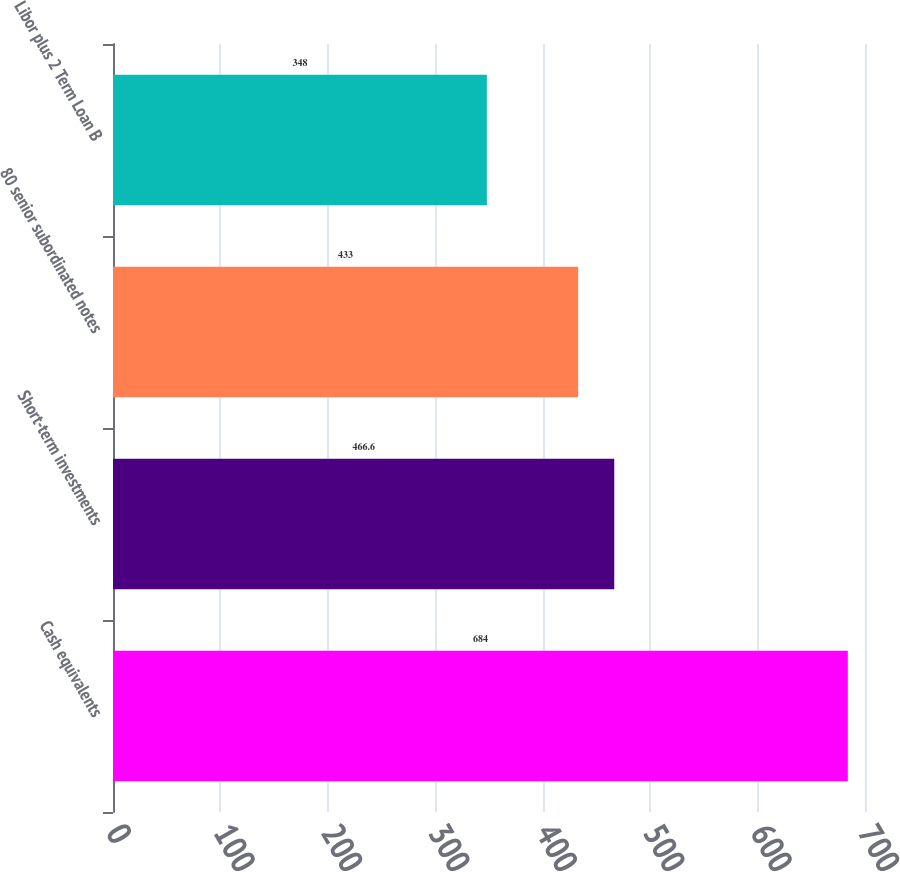<chart> <loc_0><loc_0><loc_500><loc_500><bar_chart><fcel>Cash equivalents<fcel>Short-term investments<fcel>80 senior subordinated notes<fcel>Libor plus 2 Term Loan B<nl><fcel>684<fcel>466.6<fcel>433<fcel>348<nl></chart> 